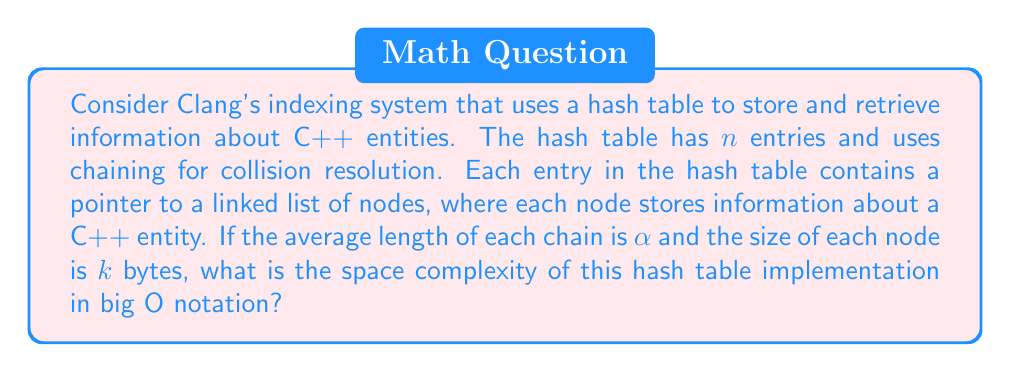Provide a solution to this math problem. To calculate the space complexity of the hash table implementation, we need to consider the following components:

1. The hash table array:
   - The hash table contains $n$ entries
   - Each entry is a pointer, which typically requires 8 bytes on a 64-bit system

2. The linked list nodes:
   - On average, there are $\alpha$ nodes per chain
   - There are $n$ chains in total
   - Each node contains:
     a. The data (k bytes)
     b. A pointer to the next node (8 bytes)

Let's calculate the total space used:

1. Space for the hash table array:
   $$S_{array} = n \cdot 8 \text{ bytes}$$

2. Space for all the linked list nodes:
   $$S_{nodes} = n \cdot \alpha \cdot (k + 8) \text{ bytes}$$

Total space:
$$S_{total} = S_{array} + S_{nodes} = n \cdot 8 + n \cdot \alpha \cdot (k + 8)$$

Simplifying:
$$S_{total} = n \cdot (8 + \alpha \cdot (k + 8))$$

In big O notation, we consider the worst-case scenario and ignore constant factors. Since $\alpha$, $k$, and 8 are all constants, we can simplify the expression to:

$$O(n)$$

This means the space complexity grows linearly with the number of entries in the hash table.
Answer: $O(n)$ 